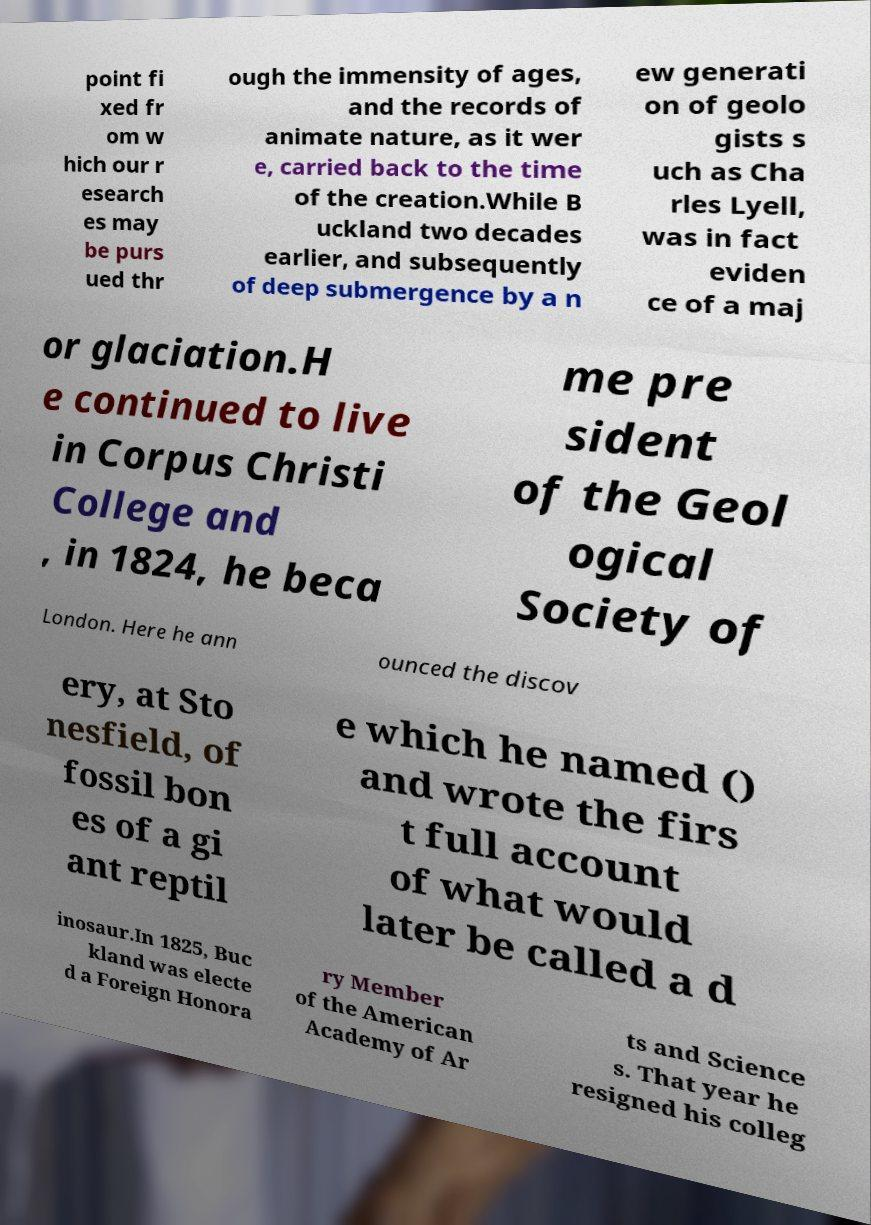Please read and relay the text visible in this image. What does it say? point fi xed fr om w hich our r esearch es may be purs ued thr ough the immensity of ages, and the records of animate nature, as it wer e, carried back to the time of the creation.While B uckland two decades earlier, and subsequently of deep submergence by a n ew generati on of geolo gists s uch as Cha rles Lyell, was in fact eviden ce of a maj or glaciation.H e continued to live in Corpus Christi College and , in 1824, he beca me pre sident of the Geol ogical Society of London. Here he ann ounced the discov ery, at Sto nesfield, of fossil bon es of a gi ant reptil e which he named () and wrote the firs t full account of what would later be called a d inosaur.In 1825, Buc kland was electe d a Foreign Honora ry Member of the American Academy of Ar ts and Science s. That year he resigned his colleg 